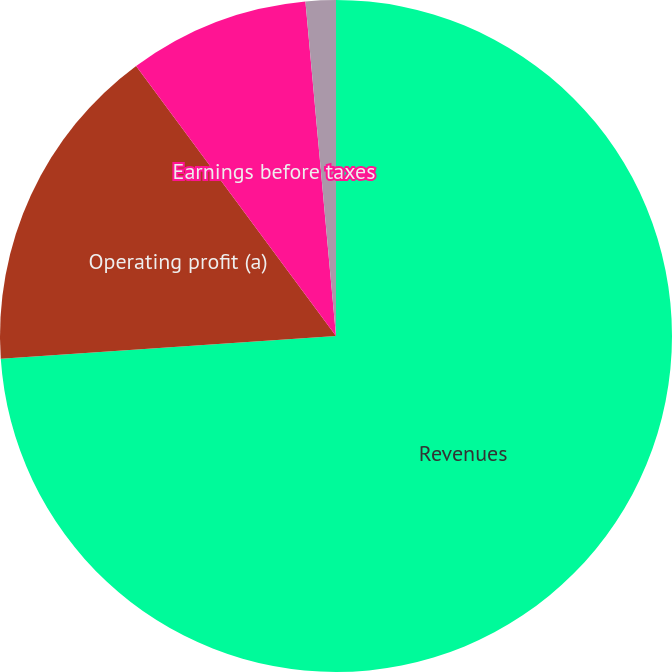Convert chart. <chart><loc_0><loc_0><loc_500><loc_500><pie_chart><fcel>Revenues<fcel>Operating profit (a)<fcel>Earnings before taxes<fcel>Net earnings of the Group<nl><fcel>73.92%<fcel>15.94%<fcel>8.69%<fcel>1.45%<nl></chart> 